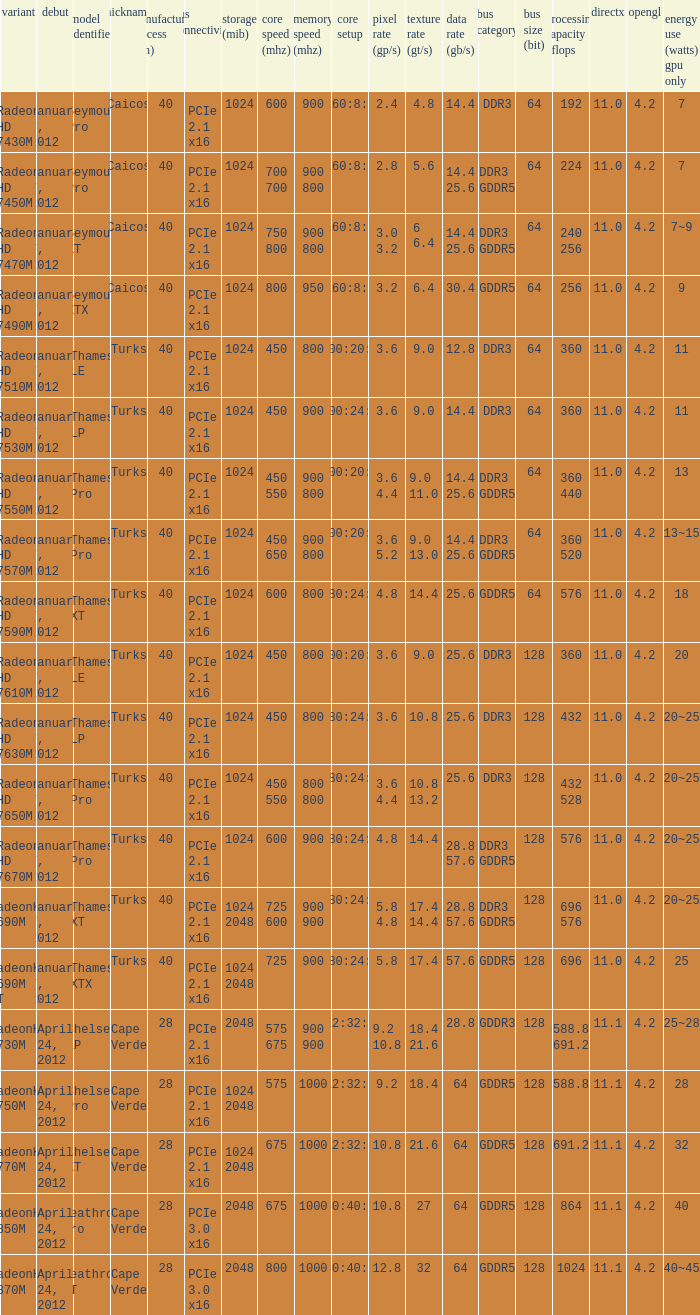What was the maximum fab (nm)? 40.0. 